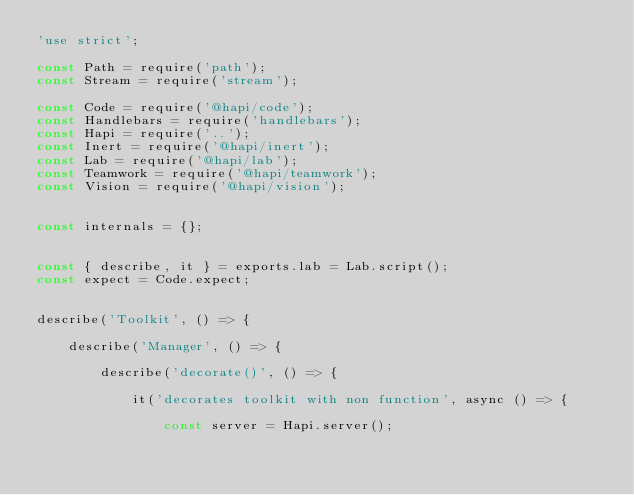Convert code to text. <code><loc_0><loc_0><loc_500><loc_500><_JavaScript_>'use strict';

const Path = require('path');
const Stream = require('stream');

const Code = require('@hapi/code');
const Handlebars = require('handlebars');
const Hapi = require('..');
const Inert = require('@hapi/inert');
const Lab = require('@hapi/lab');
const Teamwork = require('@hapi/teamwork');
const Vision = require('@hapi/vision');


const internals = {};


const { describe, it } = exports.lab = Lab.script();
const expect = Code.expect;


describe('Toolkit', () => {

    describe('Manager', () => {

        describe('decorate()', () => {

            it('decorates toolkit with non function', async () => {

                const server = Hapi.server();
</code> 